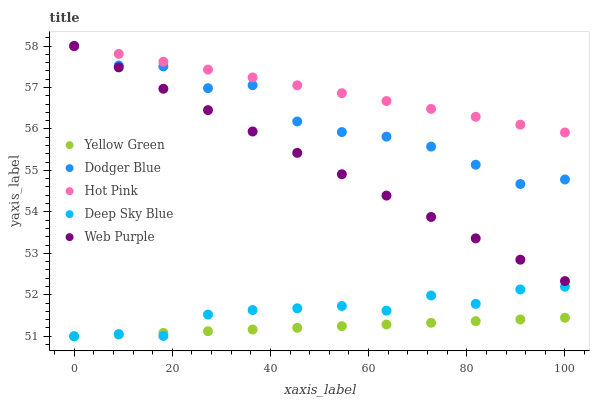Does Yellow Green have the minimum area under the curve?
Answer yes or no. Yes. Does Hot Pink have the maximum area under the curve?
Answer yes or no. Yes. Does Dodger Blue have the minimum area under the curve?
Answer yes or no. No. Does Dodger Blue have the maximum area under the curve?
Answer yes or no. No. Is Yellow Green the smoothest?
Answer yes or no. Yes. Is Dodger Blue the roughest?
Answer yes or no. Yes. Is Hot Pink the smoothest?
Answer yes or no. No. Is Hot Pink the roughest?
Answer yes or no. No. Does Yellow Green have the lowest value?
Answer yes or no. Yes. Does Dodger Blue have the lowest value?
Answer yes or no. No. Does Dodger Blue have the highest value?
Answer yes or no. Yes. Does Yellow Green have the highest value?
Answer yes or no. No. Is Yellow Green less than Hot Pink?
Answer yes or no. Yes. Is Web Purple greater than Yellow Green?
Answer yes or no. Yes. Does Deep Sky Blue intersect Yellow Green?
Answer yes or no. Yes. Is Deep Sky Blue less than Yellow Green?
Answer yes or no. No. Is Deep Sky Blue greater than Yellow Green?
Answer yes or no. No. Does Yellow Green intersect Hot Pink?
Answer yes or no. No. 